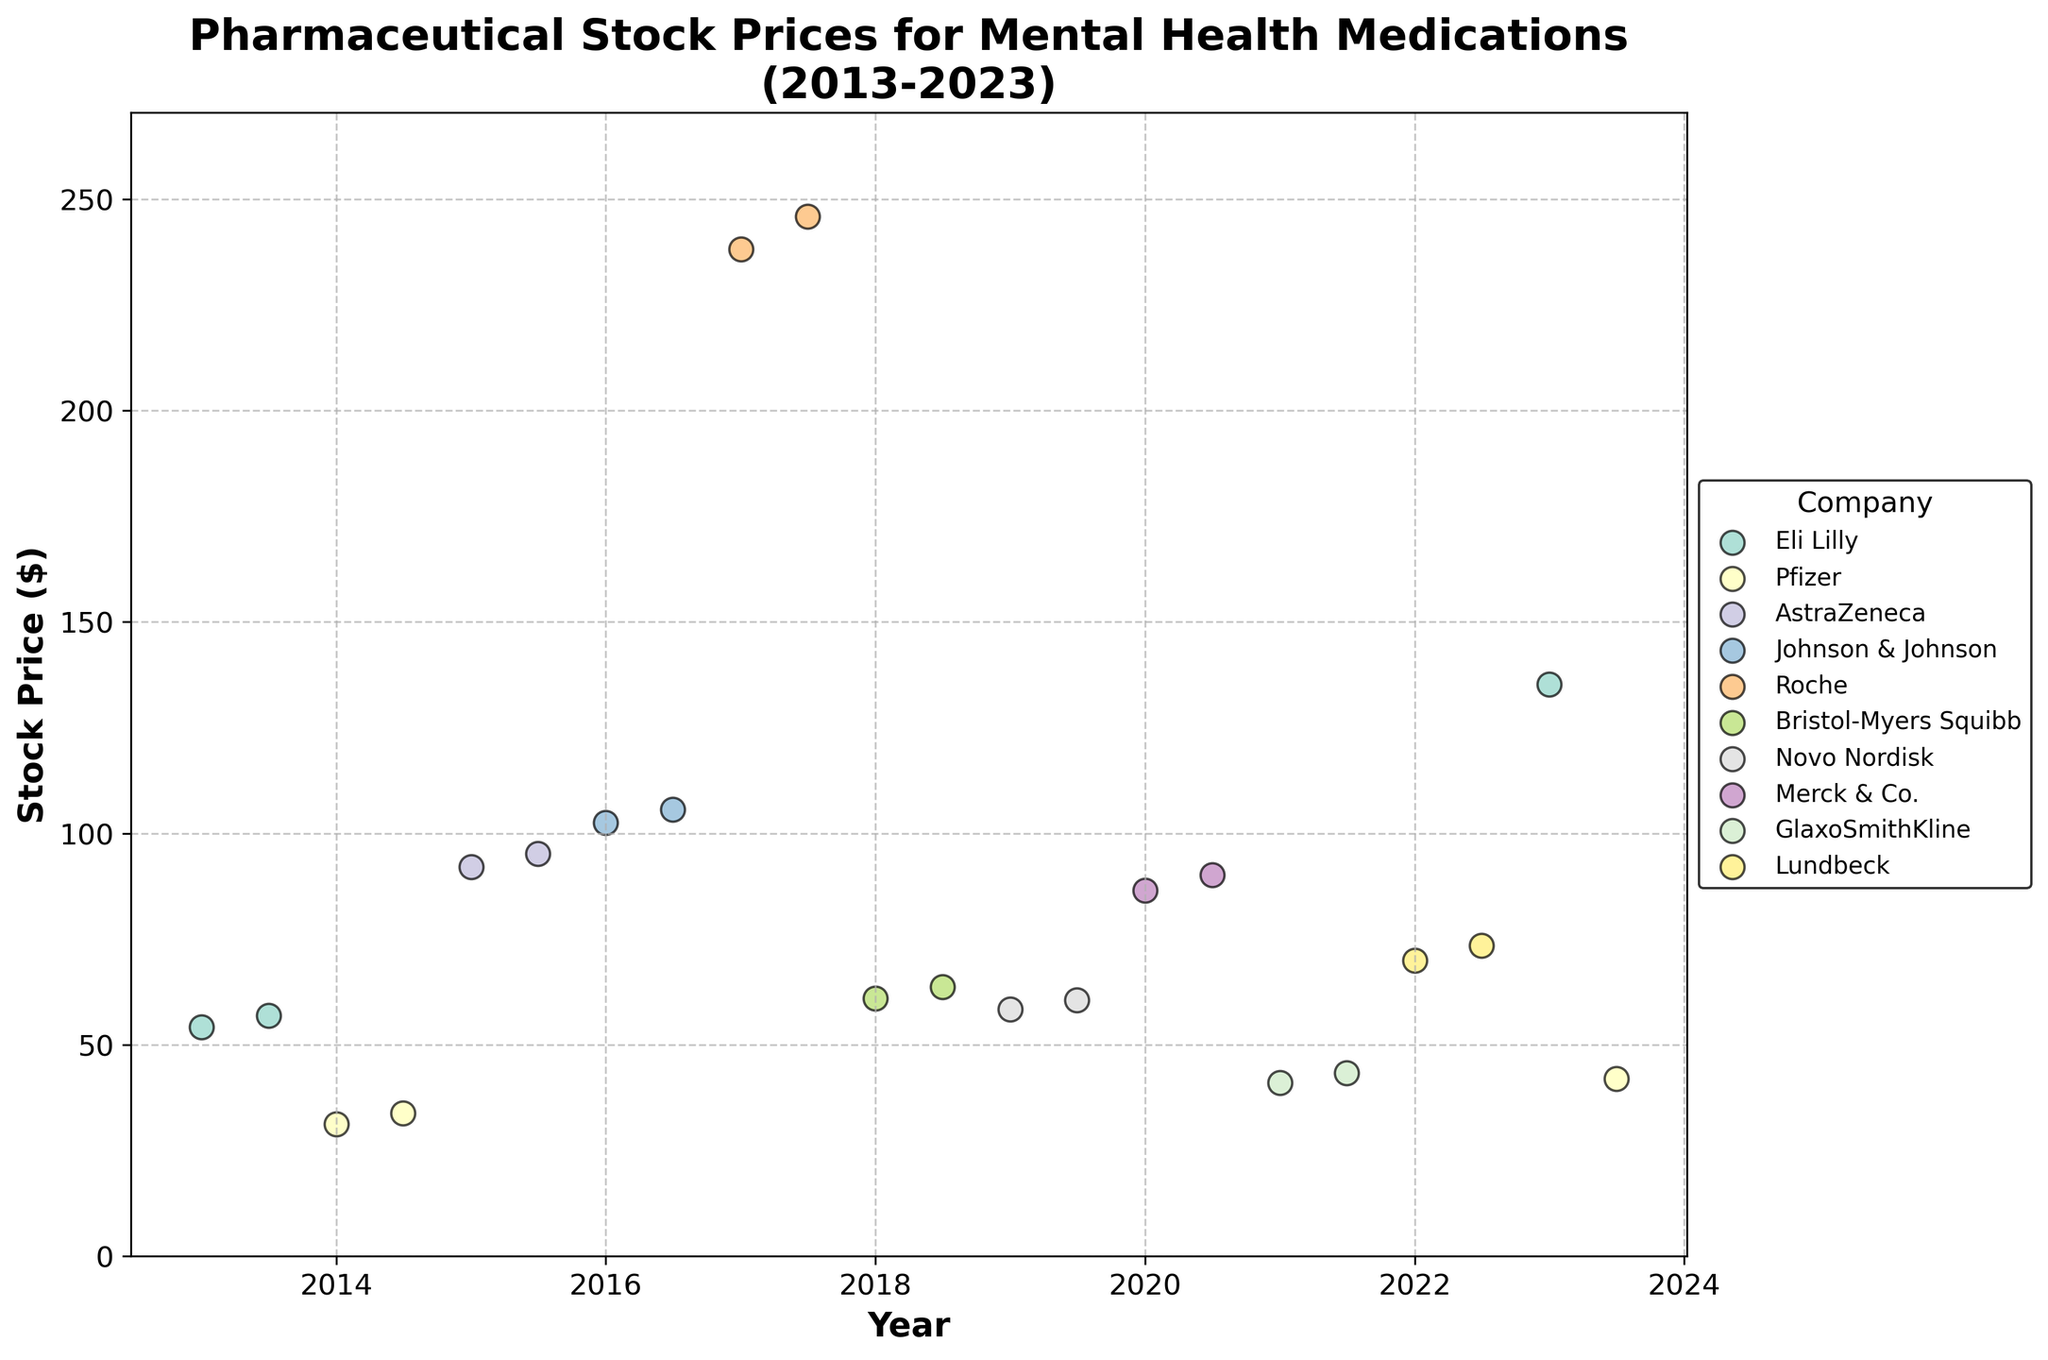What is the title of the plot? The title of the plot is located at the top, which gives a clear description of what the plot represents. In this case, it reads "Pharmaceutical Stock Prices for Mental Health Medications (2013-2023)."
Answer: Pharmaceutical Stock Prices for Mental Health Medications (2013-2023) Which company has the highest stock price in the plot? To find the highest stock price, look at the y-axis for the highest value, and then check the corresponding company label from the legend or data points. The highest value on the y-axis is 245.87, which corresponds to Roche.
Answer: Roche How many different companies are represented in the plot? Each company is represented by a unique color in the scatter plot. By counting the number of unique colors or companies listed in the legend, we find that there are 10 different companies.
Answer: 10 What is the stock price of Eli Lilly's Zyprexa in January 2023? Find the data point corresponding to Eli Lilly, then trace it to January 2023 on the x-axis to see its stock price on the y-axis. It is labeled as 135.23.
Answer: 135.23 Which year shows a significant increase in the stock price of Eli Lilly's Zyprexa? By tracking the stock prices of Eli Lilly's Zyprexa over different years and identifying a significant upward trend, we observe a sharp increase between 2013 and 2023.
Answer: Between 2013 and 2023 Compare the stock prices of Zoloft in 2014 and 2023. Which year had a higher value? Locate the data points for Zoloft by the company Pfizer in 2014 and 2023, then compare their y-axis values. In 2014, Zoloft's price is 31.25, and in 2023, it is 41.94.
Answer: 2023 What is the overall trend of the stock prices for mental health medications from 2013 to 2023? By observing the general direction of the data points over the years, it is evident that stock prices for mental health medications overall show an upward trend from 2013 to 2023.
Answer: Upward trend What is the average stock price of drugs listed under Pfizer in 2014? Identify all data points for Pfizer in 2014, which are Zoloft at 31.25 and Effexor at 33.77. Calculate the average: (31.25 + 33.77) / 2 = 32.51.
Answer: 32.51 Which company has the largest difference between two data points in the plot and what is that difference? To determine the largest difference, compare the highest and lowest stock prices for each company's data points within the plot. Eli Lilly has data points of 54.23 and 135.23, giving a difference of 135.23 - 54.23 = 81.
Answer: Eli Lilly, 81 